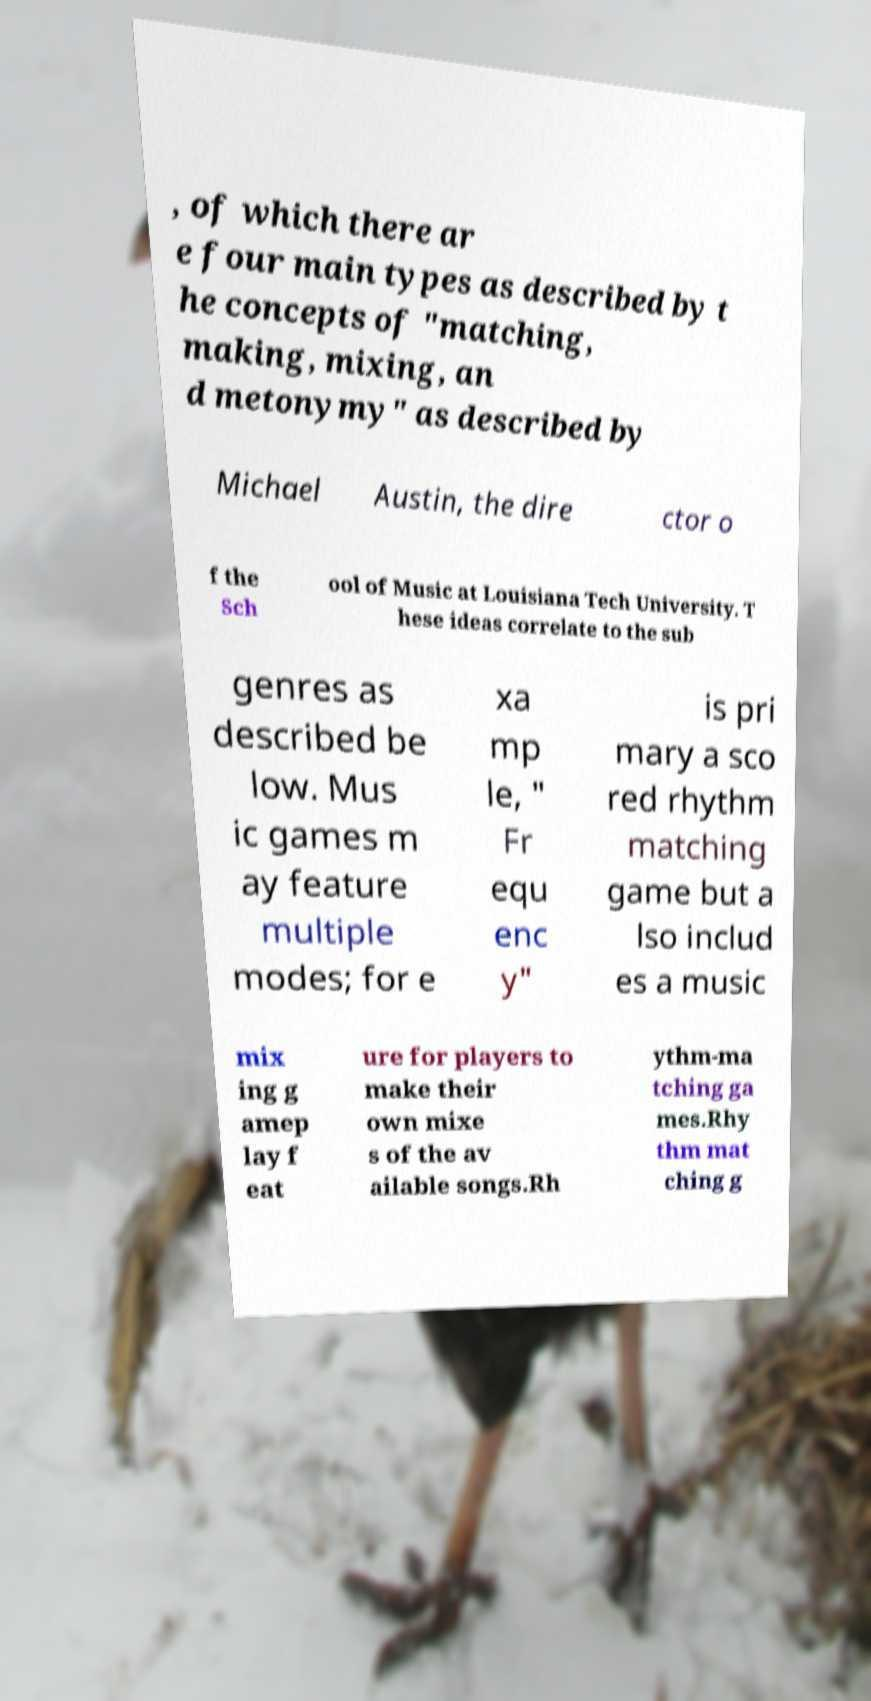Can you read and provide the text displayed in the image?This photo seems to have some interesting text. Can you extract and type it out for me? , of which there ar e four main types as described by t he concepts of "matching, making, mixing, an d metonymy" as described by Michael Austin, the dire ctor o f the Sch ool of Music at Louisiana Tech University. T hese ideas correlate to the sub genres as described be low. Mus ic games m ay feature multiple modes; for e xa mp le, " Fr equ enc y" is pri mary a sco red rhythm matching game but a lso includ es a music mix ing g amep lay f eat ure for players to make their own mixe s of the av ailable songs.Rh ythm-ma tching ga mes.Rhy thm mat ching g 